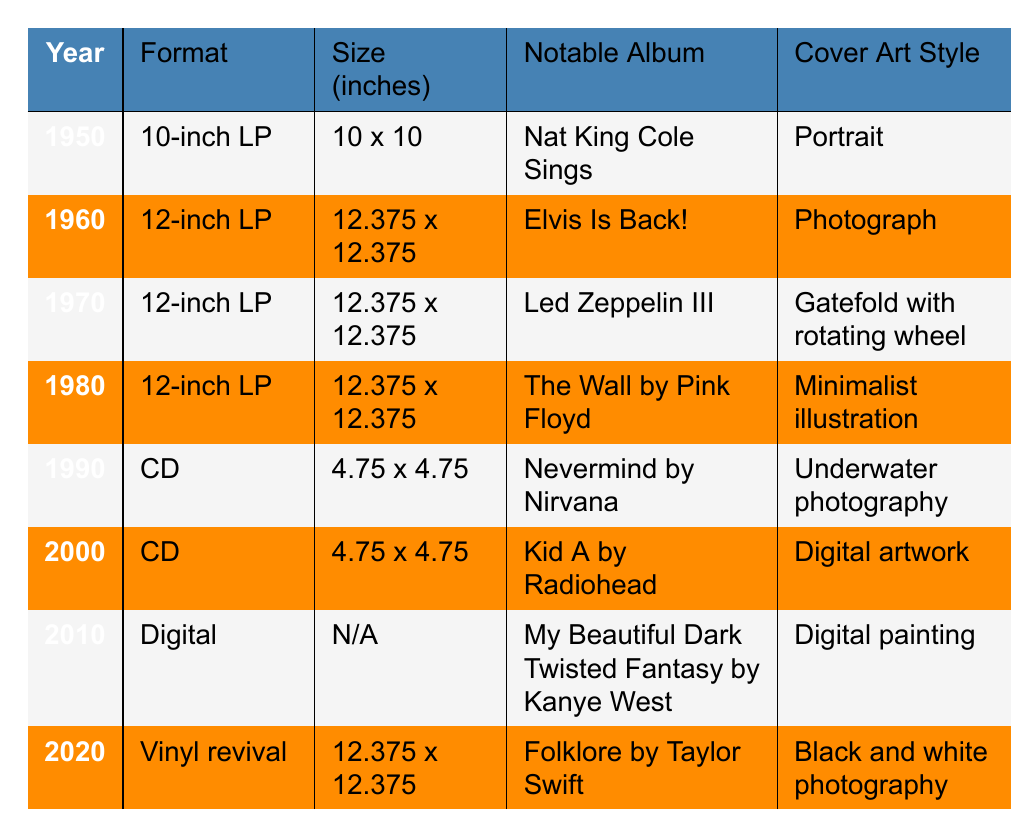What was the notable album for the year 1970? The table indicates that the notable album for 1970 is "Led Zeppelin III."
Answer: Led Zeppelin III Which material was primarily used for album covers in the 1960s? From the table, it shows that album covers in the 1960s were made of cardboard, as seen for both 1960 and 1970 entries.
Answer: Cardboard How many different formats of albums were listed in the table? The table lists three different formats: 10-inch LP, 12-inch LP, CD, Digital, and Vinyl revival, making a total of five different formats.
Answer: Five What was the size of the 12-inch LP album format? The table states that the size of the 12-inch LP format is 12.375 x 12.375 inches, applicable for the albums listed in 1960, 1970, 1980, and 2020.
Answer: 12.375 x 12.375 inches Which cover art style was notable for the album "Nevermind" by Nirvana? Referring to the table, the cover art style for "Nevermind" is described as underwater photography.
Answer: Underwater photography Which year saw the transition from LP formats to CD formats? The year 1990 represents a change from LP formats to CD formats, as it shows the first instance of a CD in the table.
Answer: 1990 What is the trend in album cover sizes from the 1950s to the 2020s? Analyzing the table, we can see that the size significantly decreased from 10 x 10 inches in 1950 to 4.75 x 4.75 inches in the 1990s, but returned to 12.375 x 12.375 inches for the vinyl revival in 2020, indicating a revival of larger sizes.
Answer: Size decreased and then revived Was "My Beautiful Dark Twisted Fantasy" available in a physical format? According to the table, "My Beautiful Dark Twisted Fantasy" is a digital album with the material listed as a digital file, indicating it was not available in a physical format.
Answer: No Which cover art style was used for the vinyl revival album "Folklore" by Taylor Swift? The table specifies that the cover art style for "Folklore" is black and white photography.
Answer: Black and white photography What material was used for the cover of "Kid A" by Radiohead? The table states that "Kid A" was packaged in a plastic digipak, identifying the material used for its cover.
Answer: Plastic digipak 